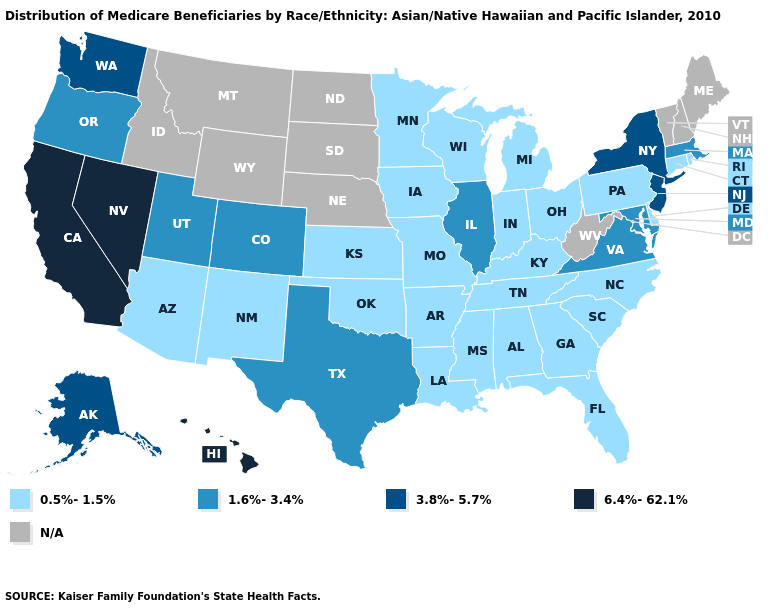What is the highest value in the USA?
Quick response, please. 6.4%-62.1%. What is the highest value in the South ?
Be succinct. 1.6%-3.4%. Among the states that border California , does Arizona have the lowest value?
Answer briefly. Yes. What is the value of New Hampshire?
Write a very short answer. N/A. Does the map have missing data?
Answer briefly. Yes. What is the highest value in the USA?
Keep it brief. 6.4%-62.1%. Does Virginia have the lowest value in the USA?
Be succinct. No. Does the map have missing data?
Answer briefly. Yes. What is the highest value in states that border Arizona?
Quick response, please. 6.4%-62.1%. Name the states that have a value in the range 1.6%-3.4%?
Short answer required. Colorado, Illinois, Maryland, Massachusetts, Oregon, Texas, Utah, Virginia. Among the states that border Florida , which have the highest value?
Write a very short answer. Alabama, Georgia. What is the value of New Hampshire?
Short answer required. N/A. Does the first symbol in the legend represent the smallest category?
Answer briefly. Yes. What is the value of Minnesota?
Be succinct. 0.5%-1.5%. Which states hav the highest value in the Northeast?
Short answer required. New Jersey, New York. 